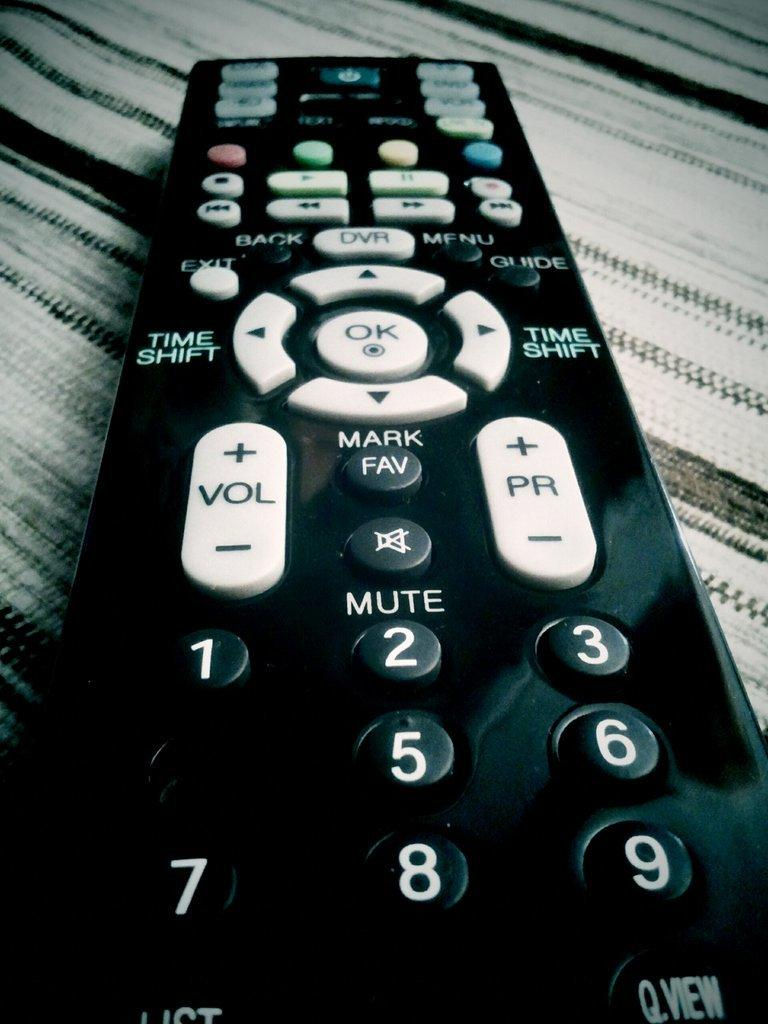Provide a one-sentence caption for the provided image. A close up of a remote with time shift and mute button among other ones. 